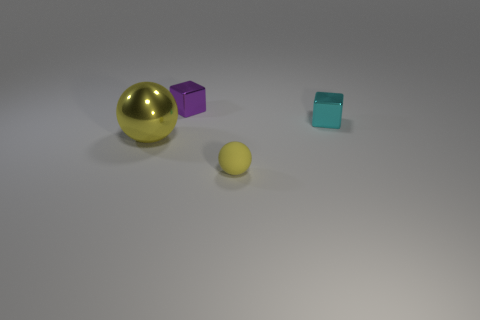Add 3 small yellow objects. How many objects exist? 7 Add 2 yellow rubber objects. How many yellow rubber objects are left? 3 Add 4 purple things. How many purple things exist? 5 Subtract 0 blue balls. How many objects are left? 4 Subtract all tiny yellow objects. Subtract all cyan cubes. How many objects are left? 2 